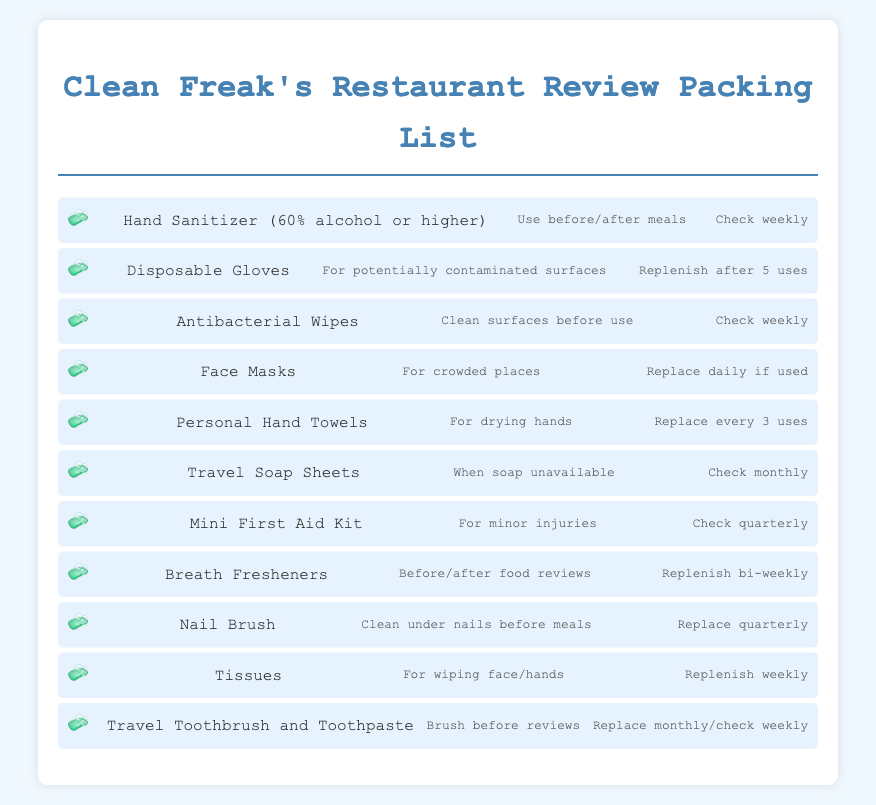What type of hand sanitizer is recommended? The document specifies that hand sanitizer should be 60% alcohol or higher.
Answer: 60% alcohol or higher How often should you check the supply of antibacterial wipes? The packing list indicates that you should check antibacterial wipes weekly.
Answer: Weekly What item should be replaced daily if used? The document states that face masks should be replaced daily if used.
Answer: Face Masks What is the purpose of the nail brush? The usage guideline for the nail brush is to clean under nails before meals.
Answer: Clean under nails before meals How often should breath fresheners be replenished? The document mentions that breath fresheners should be replenished bi-weekly.
Answer: Bi-weekly What item is suggested for drying hands? The packing list indicates that personal hand towels are suggested for drying hands.
Answer: Personal Hand Towels How frequently should disposable gloves be replenished? The document specifies that disposable gloves should be replenished after 5 uses.
Answer: After 5 uses What is the usage recommendation for travel soap sheets? The document states that travel soap sheets should be used when soap is unavailable.
Answer: When soap unavailable How often should tissues be replenished? The packing list indicates that tissues should be replenished weekly.
Answer: Weekly 